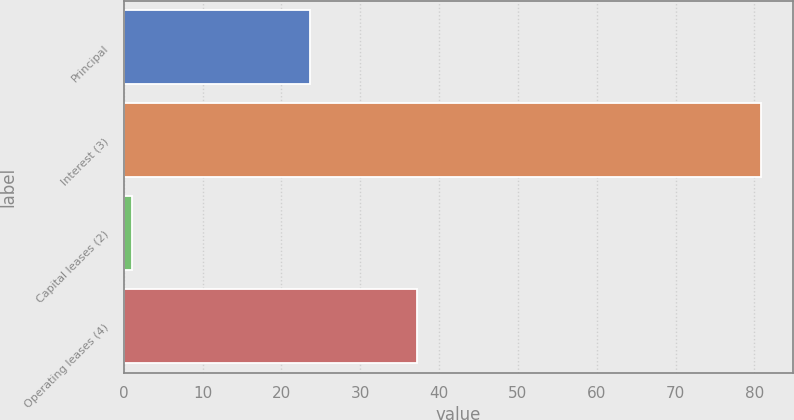<chart> <loc_0><loc_0><loc_500><loc_500><bar_chart><fcel>Principal<fcel>Interest (3)<fcel>Capital leases (2)<fcel>Operating leases (4)<nl><fcel>23.6<fcel>80.8<fcel>1<fcel>37.2<nl></chart> 